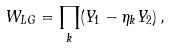Convert formula to latex. <formula><loc_0><loc_0><loc_500><loc_500>W _ { L G } = \prod _ { k } ( Y _ { 1 } - \eta _ { k } Y _ { 2 } ) \, ,</formula> 